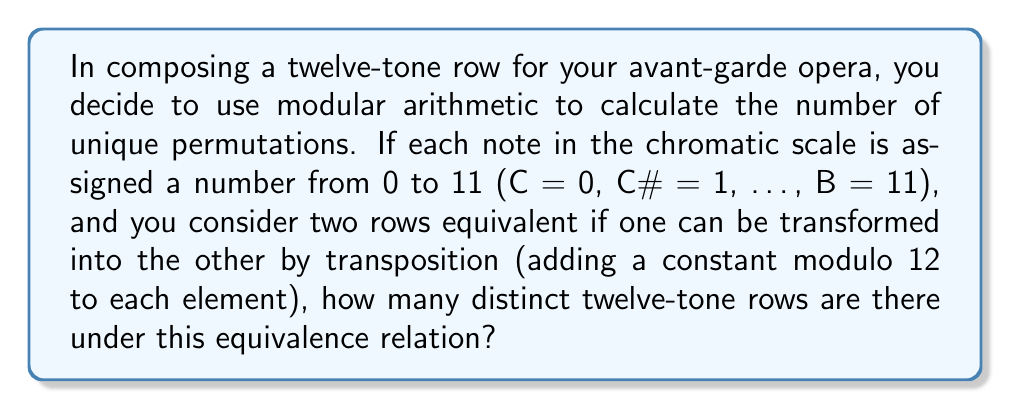Help me with this question. Let's approach this step-by-step:

1) First, we need to understand that without considering transposition, there are 12! (12 factorial) possible permutations of 12 distinct elements.

2) However, we're considering rows equivalent if they can be transposed into each other. This means each unique row actually represents a class of 12 equivalent rows (one for each possible transposition).

3) To find the number of distinct classes, we need to divide the total number of permutations by the number of elements in each class:

   $$\text{Number of distinct classes} = \frac{\text{Total permutations}}{\text{Elements per class}} = \frac{12!}{12}$$

4) Let's calculate this:
   
   $$\frac{12!}{12} = \frac{479,001,600}{12} = 39,916,800$$

5) This result can be simplified further. Notice that:

   $$\frac{12!}{12} = 11!$$

6) This makes sense musically: once we fix the first note of our row (effectively choosing a transposition), we have 11 choices for the second note, 10 for the third, and so on, giving us 11! total possibilities.
Answer: There are 39,916,800 (which is equal to 11!) distinct twelve-tone rows under this equivalence relation. 